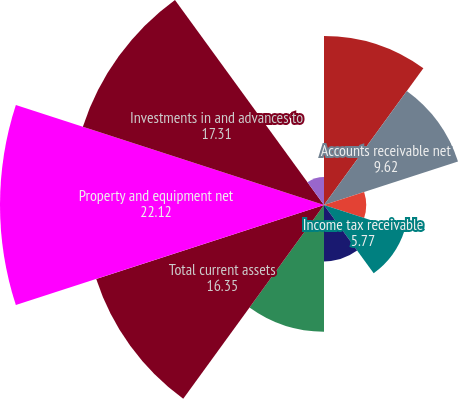<chart> <loc_0><loc_0><loc_500><loc_500><pie_chart><fcel>Cash and cash equivalents<fcel>Accounts receivable net<fcel>Inventories<fcel>Income tax receivable<fcel>Deferred income taxes<fcel>Prepaid expenses and other<fcel>Total current assets<fcel>Property and equipment net<fcel>Investments in and advances to<fcel>Goodwill<nl><fcel>11.54%<fcel>9.62%<fcel>2.88%<fcel>5.77%<fcel>3.85%<fcel>8.65%<fcel>16.35%<fcel>22.12%<fcel>17.31%<fcel>1.92%<nl></chart> 